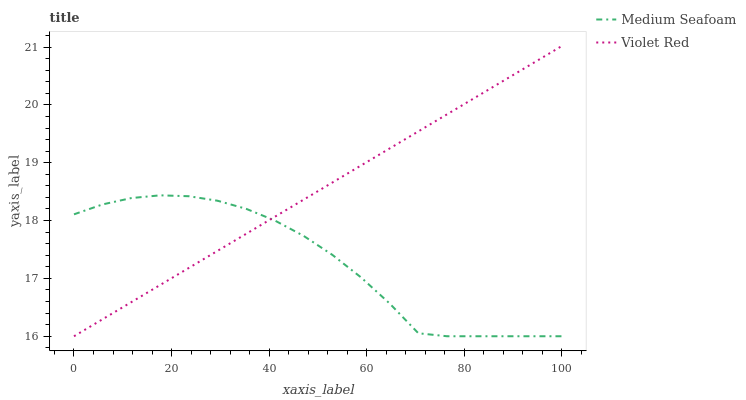Does Medium Seafoam have the minimum area under the curve?
Answer yes or no. Yes. Does Violet Red have the maximum area under the curve?
Answer yes or no. Yes. Does Medium Seafoam have the maximum area under the curve?
Answer yes or no. No. Is Violet Red the smoothest?
Answer yes or no. Yes. Is Medium Seafoam the roughest?
Answer yes or no. Yes. Is Medium Seafoam the smoothest?
Answer yes or no. No. Does Violet Red have the lowest value?
Answer yes or no. Yes. Does Violet Red have the highest value?
Answer yes or no. Yes. Does Medium Seafoam have the highest value?
Answer yes or no. No. Does Medium Seafoam intersect Violet Red?
Answer yes or no. Yes. Is Medium Seafoam less than Violet Red?
Answer yes or no. No. Is Medium Seafoam greater than Violet Red?
Answer yes or no. No. 